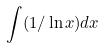Convert formula to latex. <formula><loc_0><loc_0><loc_500><loc_500>\int ( 1 / \ln x ) d x</formula> 